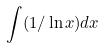Convert formula to latex. <formula><loc_0><loc_0><loc_500><loc_500>\int ( 1 / \ln x ) d x</formula> 